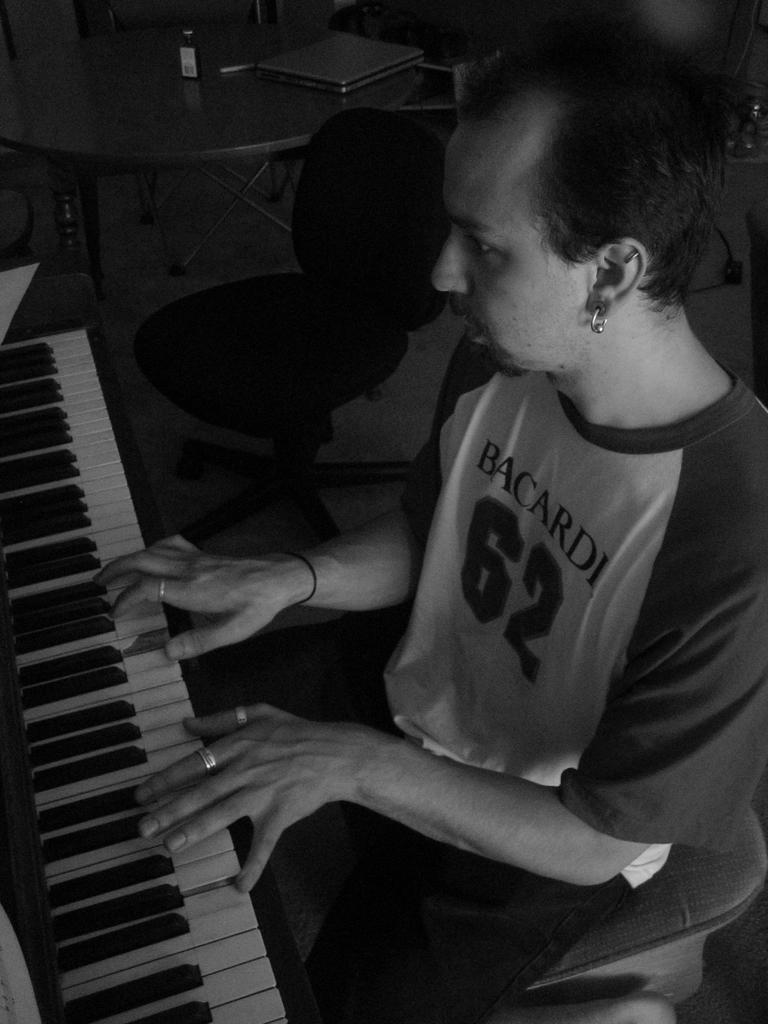What is the person in the image doing? The person is sitting and playing a piano. What type of furniture is present in the image? There is a chair and a table in the image. What objects are on the table? There is a bottle and a laptop on the table. What type of doll is sitting next to the person playing the piano? There is no doll present in the image. What type of band is performing in the background of the image? There is no band present in the image. 